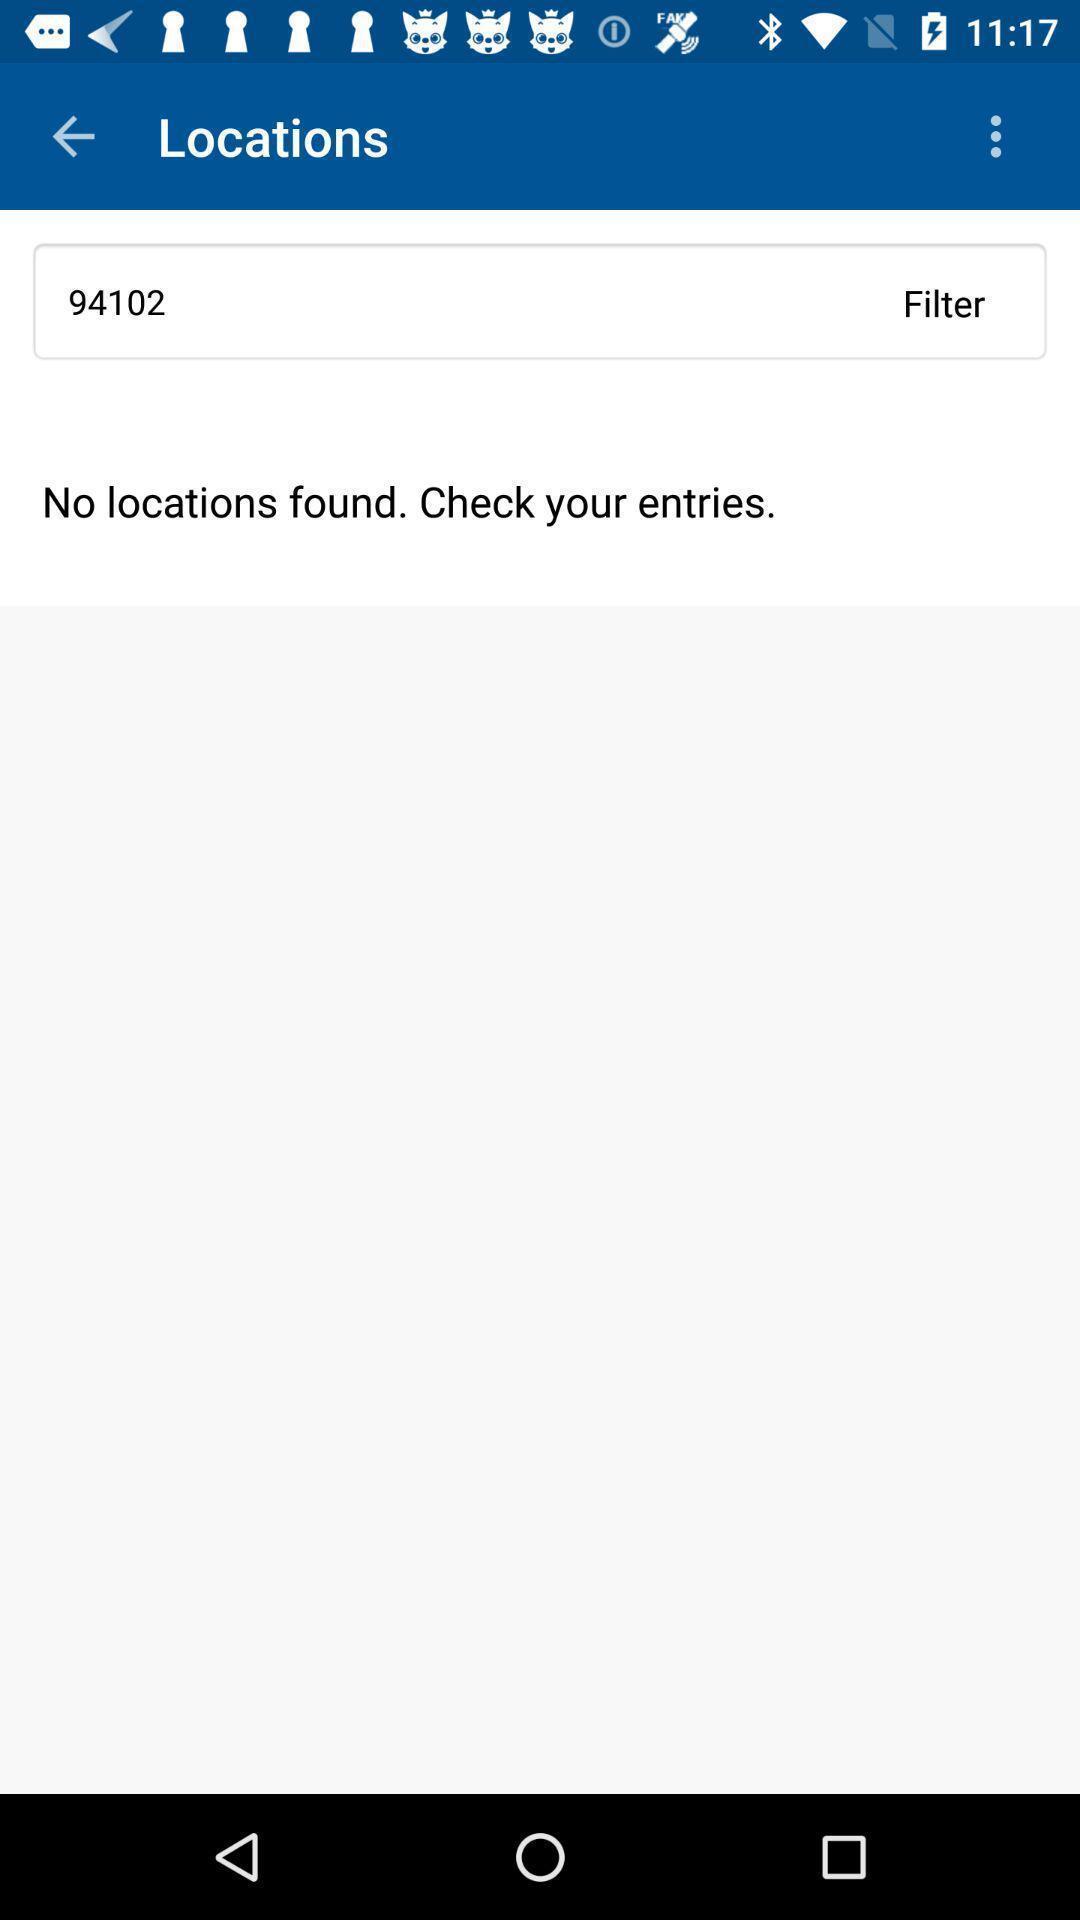Give me a narrative description of this picture. Page showing no locations for entries. 